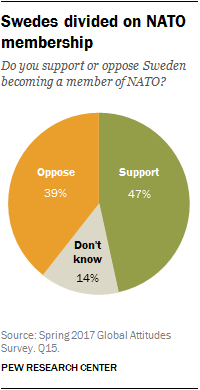Point out several critical features in this image. The value of Oppose and Support is 8, and that's all there is to it. The color of the "Support" pie of the graph is green. 